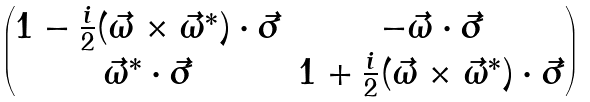Convert formula to latex. <formula><loc_0><loc_0><loc_500><loc_500>\begin{pmatrix} 1 - \frac { i } { 2 } ( \vec { \omega } \times \vec { \omega } ^ { * } ) \cdot \vec { \sigma } & - \vec { \omega } \cdot \vec { \sigma } \\ \vec { \omega } ^ { * } \cdot \vec { \sigma } & 1 + \frac { i } { 2 } ( \vec { \omega } \times \vec { \omega } ^ { * } ) \cdot \vec { \sigma } \end{pmatrix}</formula> 